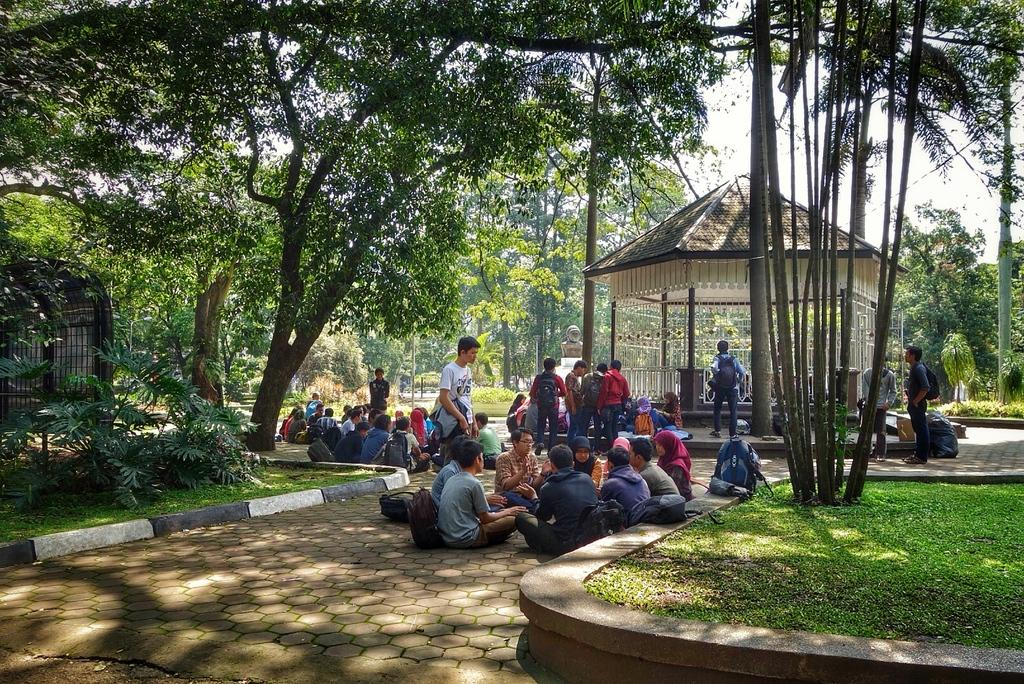How many people are in the image? There is a group of persons in the image. What are the people in the image doing? Some of the persons are sitting, and some are standing. What can be seen in the background of the image? There are trees in the background of the image. What type of fruit is hanging from the trees in the background of the image? There is no fruit visible in the image, as the background only shows trees. 